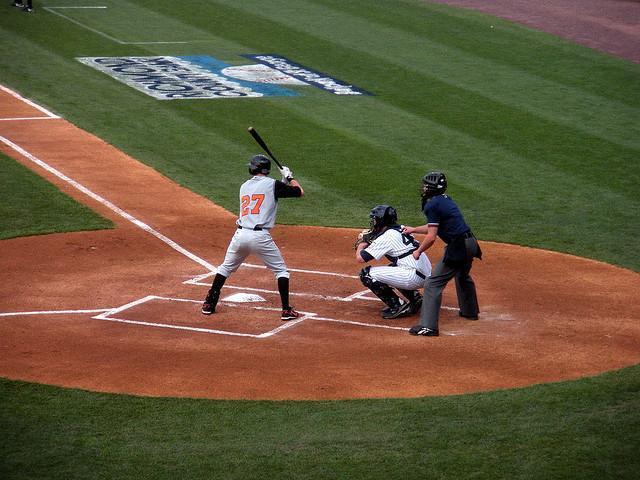How many people are in this picture?
Give a very brief answer. 3. How many people are in the picture?
Give a very brief answer. 3. 